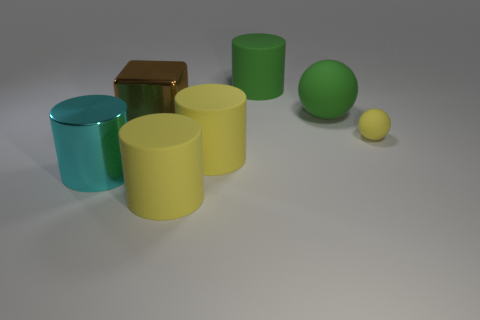Subtract all red blocks. How many yellow cylinders are left? 2 Subtract all green rubber cylinders. How many cylinders are left? 3 Subtract all cyan cylinders. How many cylinders are left? 3 Subtract all gray cylinders. Subtract all blue blocks. How many cylinders are left? 4 Add 3 large green objects. How many objects exist? 10 Subtract all cubes. How many objects are left? 6 Subtract all tiny cyan matte blocks. Subtract all large matte cylinders. How many objects are left? 4 Add 7 big green rubber things. How many big green rubber things are left? 9 Add 7 yellow objects. How many yellow objects exist? 10 Subtract 0 brown balls. How many objects are left? 7 